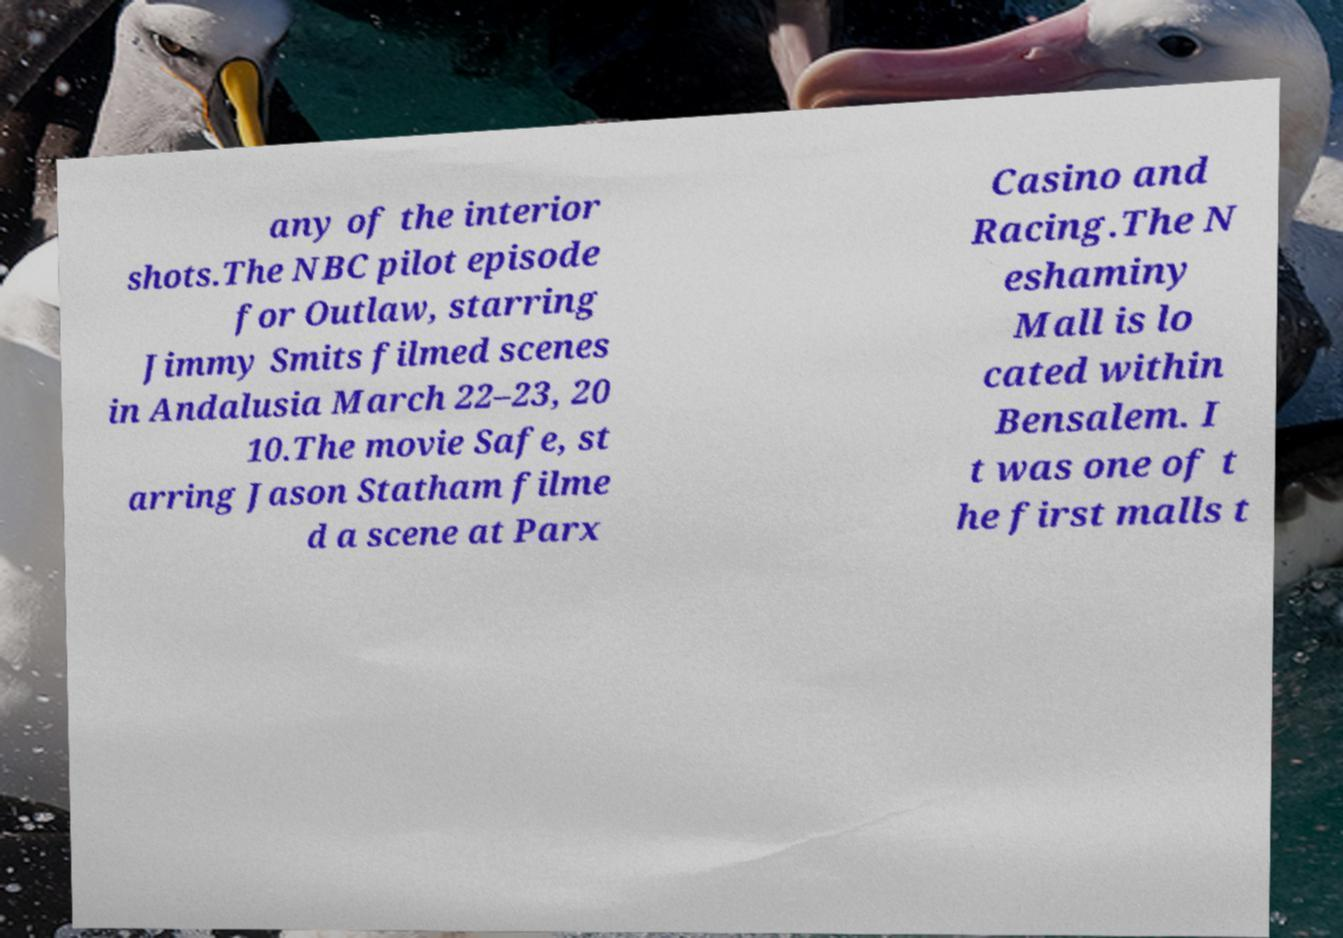Can you read and provide the text displayed in the image?This photo seems to have some interesting text. Can you extract and type it out for me? any of the interior shots.The NBC pilot episode for Outlaw, starring Jimmy Smits filmed scenes in Andalusia March 22–23, 20 10.The movie Safe, st arring Jason Statham filme d a scene at Parx Casino and Racing.The N eshaminy Mall is lo cated within Bensalem. I t was one of t he first malls t 